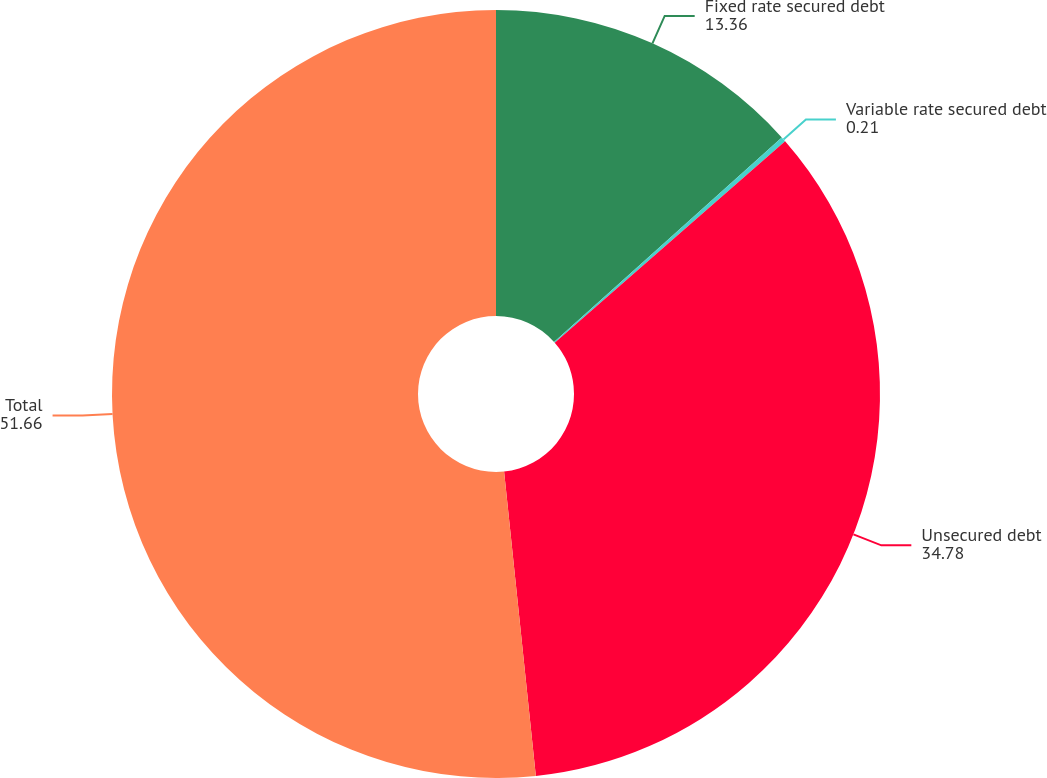Convert chart. <chart><loc_0><loc_0><loc_500><loc_500><pie_chart><fcel>Fixed rate secured debt<fcel>Variable rate secured debt<fcel>Unsecured debt<fcel>Total<nl><fcel>13.36%<fcel>0.21%<fcel>34.78%<fcel>51.66%<nl></chart> 